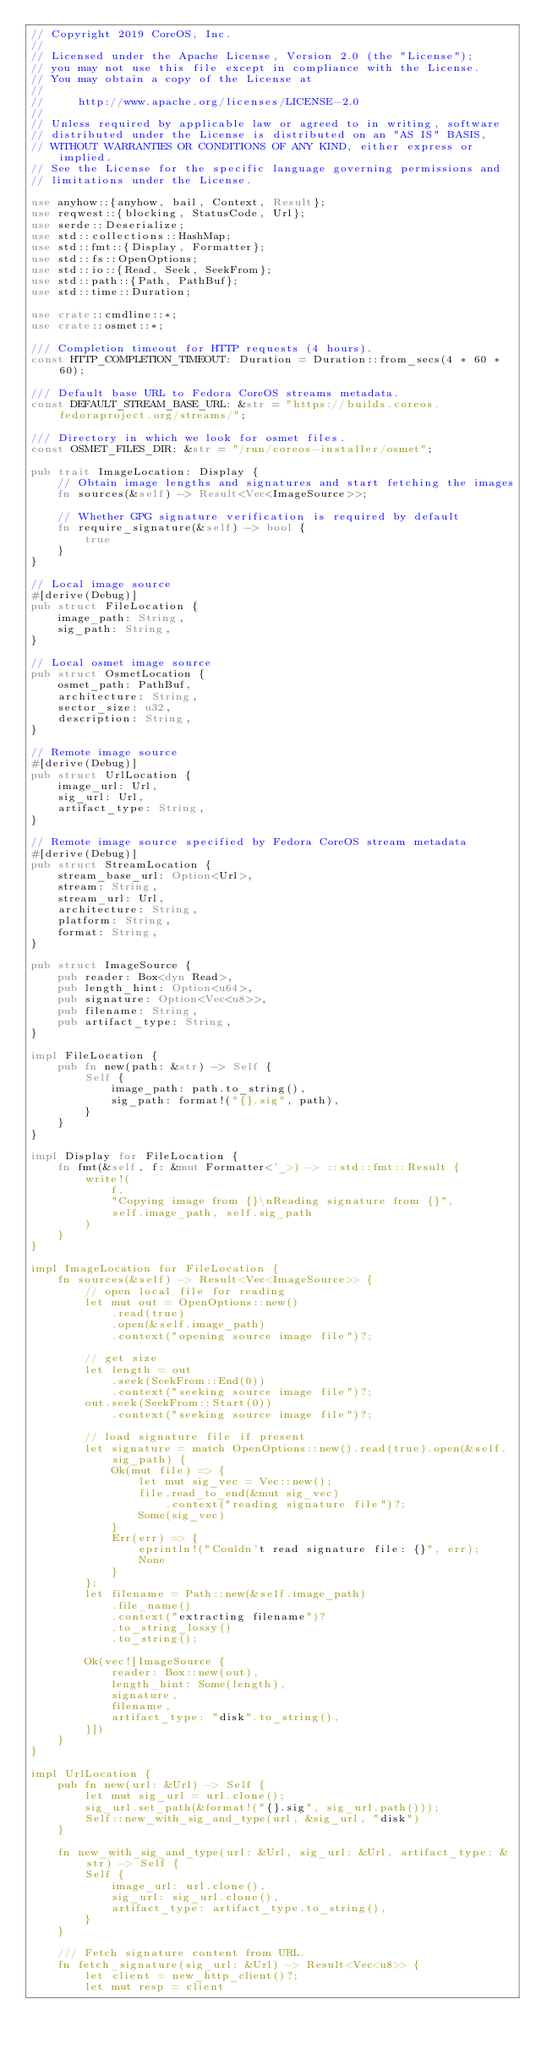Convert code to text. <code><loc_0><loc_0><loc_500><loc_500><_Rust_>// Copyright 2019 CoreOS, Inc.
//
// Licensed under the Apache License, Version 2.0 (the "License");
// you may not use this file except in compliance with the License.
// You may obtain a copy of the License at
//
//     http://www.apache.org/licenses/LICENSE-2.0
//
// Unless required by applicable law or agreed to in writing, software
// distributed under the License is distributed on an "AS IS" BASIS,
// WITHOUT WARRANTIES OR CONDITIONS OF ANY KIND, either express or implied.
// See the License for the specific language governing permissions and
// limitations under the License.

use anyhow::{anyhow, bail, Context, Result};
use reqwest::{blocking, StatusCode, Url};
use serde::Deserialize;
use std::collections::HashMap;
use std::fmt::{Display, Formatter};
use std::fs::OpenOptions;
use std::io::{Read, Seek, SeekFrom};
use std::path::{Path, PathBuf};
use std::time::Duration;

use crate::cmdline::*;
use crate::osmet::*;

/// Completion timeout for HTTP requests (4 hours).
const HTTP_COMPLETION_TIMEOUT: Duration = Duration::from_secs(4 * 60 * 60);

/// Default base URL to Fedora CoreOS streams metadata.
const DEFAULT_STREAM_BASE_URL: &str = "https://builds.coreos.fedoraproject.org/streams/";

/// Directory in which we look for osmet files.
const OSMET_FILES_DIR: &str = "/run/coreos-installer/osmet";

pub trait ImageLocation: Display {
    // Obtain image lengths and signatures and start fetching the images
    fn sources(&self) -> Result<Vec<ImageSource>>;

    // Whether GPG signature verification is required by default
    fn require_signature(&self) -> bool {
        true
    }
}

// Local image source
#[derive(Debug)]
pub struct FileLocation {
    image_path: String,
    sig_path: String,
}

// Local osmet image source
pub struct OsmetLocation {
    osmet_path: PathBuf,
    architecture: String,
    sector_size: u32,
    description: String,
}

// Remote image source
#[derive(Debug)]
pub struct UrlLocation {
    image_url: Url,
    sig_url: Url,
    artifact_type: String,
}

// Remote image source specified by Fedora CoreOS stream metadata
#[derive(Debug)]
pub struct StreamLocation {
    stream_base_url: Option<Url>,
    stream: String,
    stream_url: Url,
    architecture: String,
    platform: String,
    format: String,
}

pub struct ImageSource {
    pub reader: Box<dyn Read>,
    pub length_hint: Option<u64>,
    pub signature: Option<Vec<u8>>,
    pub filename: String,
    pub artifact_type: String,
}

impl FileLocation {
    pub fn new(path: &str) -> Self {
        Self {
            image_path: path.to_string(),
            sig_path: format!("{}.sig", path),
        }
    }
}

impl Display for FileLocation {
    fn fmt(&self, f: &mut Formatter<'_>) -> ::std::fmt::Result {
        write!(
            f,
            "Copying image from {}\nReading signature from {}",
            self.image_path, self.sig_path
        )
    }
}

impl ImageLocation for FileLocation {
    fn sources(&self) -> Result<Vec<ImageSource>> {
        // open local file for reading
        let mut out = OpenOptions::new()
            .read(true)
            .open(&self.image_path)
            .context("opening source image file")?;

        // get size
        let length = out
            .seek(SeekFrom::End(0))
            .context("seeking source image file")?;
        out.seek(SeekFrom::Start(0))
            .context("seeking source image file")?;

        // load signature file if present
        let signature = match OpenOptions::new().read(true).open(&self.sig_path) {
            Ok(mut file) => {
                let mut sig_vec = Vec::new();
                file.read_to_end(&mut sig_vec)
                    .context("reading signature file")?;
                Some(sig_vec)
            }
            Err(err) => {
                eprintln!("Couldn't read signature file: {}", err);
                None
            }
        };
        let filename = Path::new(&self.image_path)
            .file_name()
            .context("extracting filename")?
            .to_string_lossy()
            .to_string();

        Ok(vec![ImageSource {
            reader: Box::new(out),
            length_hint: Some(length),
            signature,
            filename,
            artifact_type: "disk".to_string(),
        }])
    }
}

impl UrlLocation {
    pub fn new(url: &Url) -> Self {
        let mut sig_url = url.clone();
        sig_url.set_path(&format!("{}.sig", sig_url.path()));
        Self::new_with_sig_and_type(url, &sig_url, "disk")
    }

    fn new_with_sig_and_type(url: &Url, sig_url: &Url, artifact_type: &str) -> Self {
        Self {
            image_url: url.clone(),
            sig_url: sig_url.clone(),
            artifact_type: artifact_type.to_string(),
        }
    }

    /// Fetch signature content from URL.
    fn fetch_signature(sig_url: &Url) -> Result<Vec<u8>> {
        let client = new_http_client()?;
        let mut resp = client</code> 